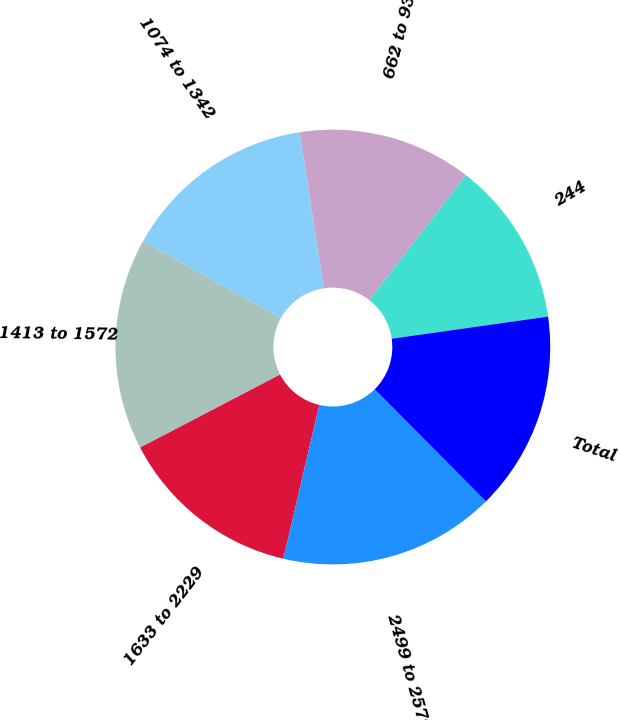Convert chart. <chart><loc_0><loc_0><loc_500><loc_500><pie_chart><fcel>244<fcel>662 to 930<fcel>1074 to 1342<fcel>1413 to 1572<fcel>1633 to 2229<fcel>2499 to 2579<fcel>Total<nl><fcel>12.29%<fcel>12.91%<fcel>14.46%<fcel>15.75%<fcel>13.69%<fcel>16.09%<fcel>14.8%<nl></chart> 